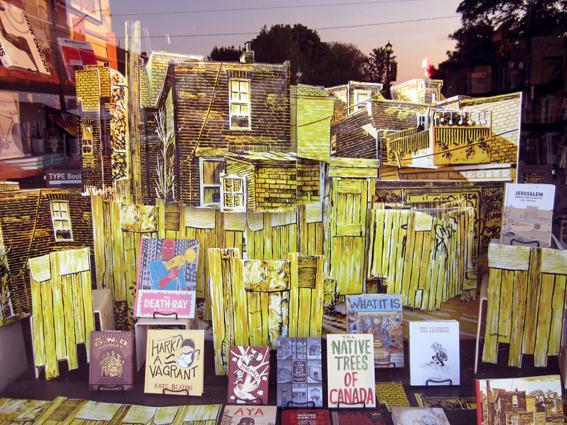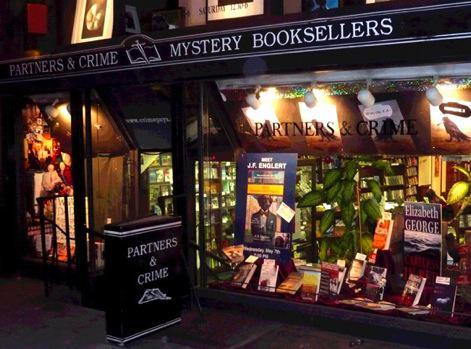The first image is the image on the left, the second image is the image on the right. Given the left and right images, does the statement "One image features a bookstore exterior showing a lighted interior, and something upright is outside in front of the store window." hold true? Answer yes or no. Yes. The first image is the image on the left, the second image is the image on the right. Analyze the images presented: Is the assertion "one of the two images contains books in chromatic order; there appears to be a rainbow effect created with books." valid? Answer yes or no. No. 